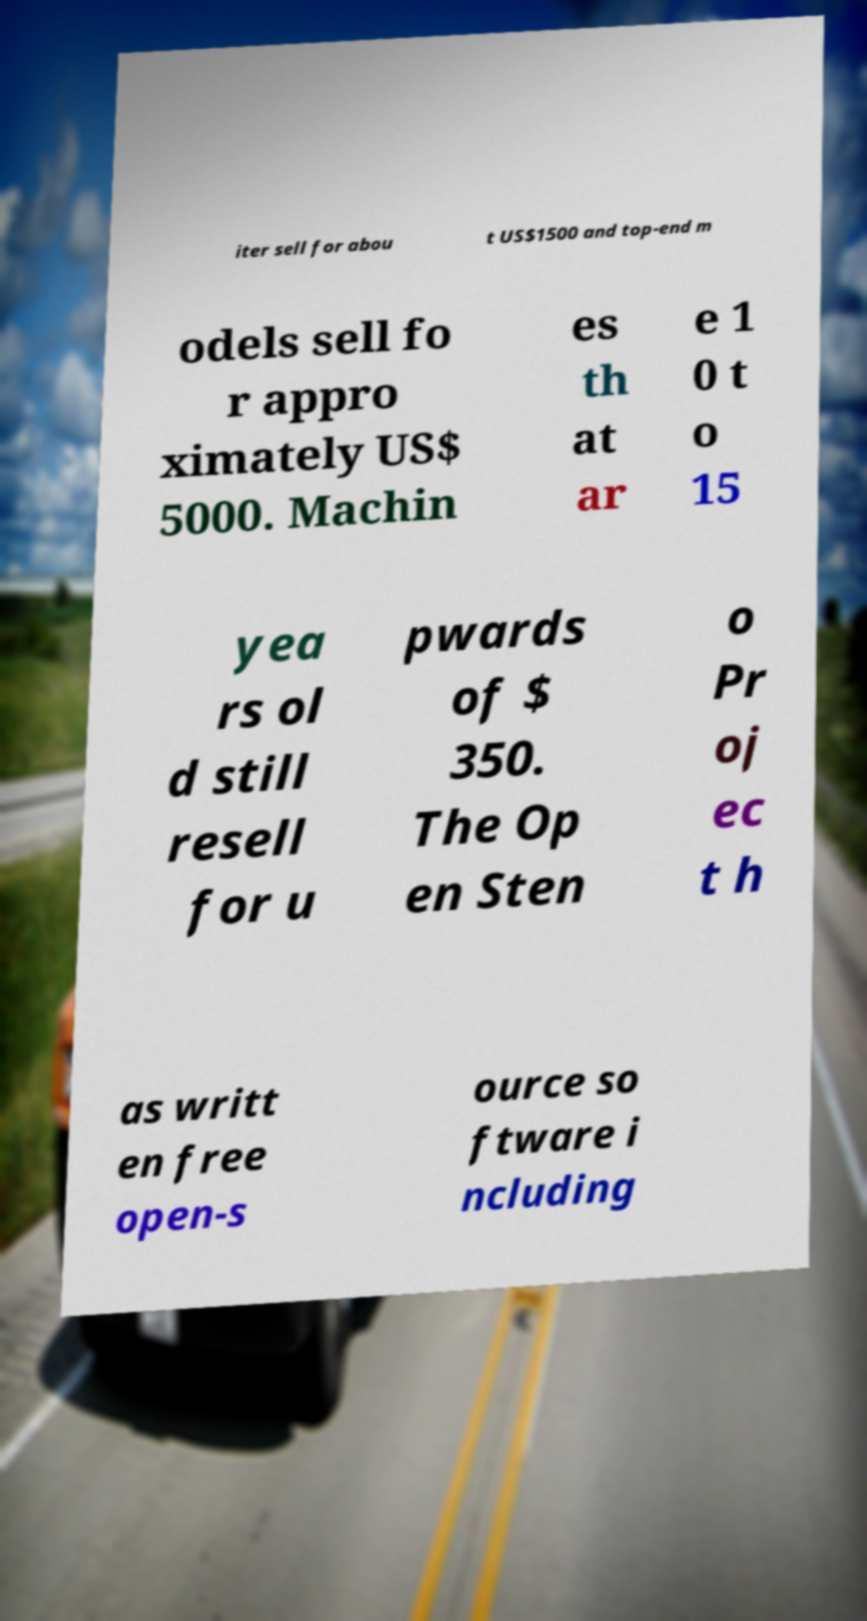What messages or text are displayed in this image? I need them in a readable, typed format. iter sell for abou t US$1500 and top-end m odels sell fo r appro ximately US$ 5000. Machin es th at ar e 1 0 t o 15 yea rs ol d still resell for u pwards of $ 350. The Op en Sten o Pr oj ec t h as writt en free open-s ource so ftware i ncluding 